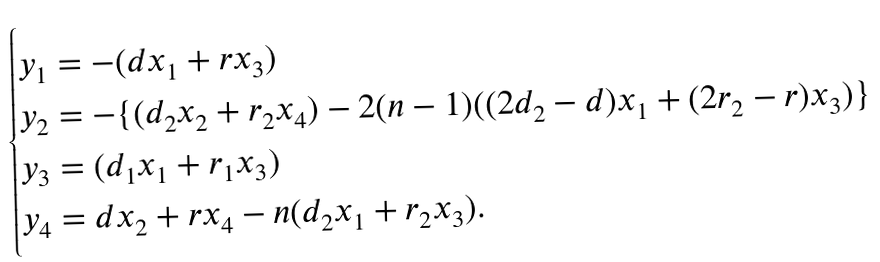Convert formula to latex. <formula><loc_0><loc_0><loc_500><loc_500>\begin{cases} y _ { 1 } = - ( d x _ { 1 } + r x _ { 3 } ) \\ y _ { 2 } = - \{ ( d _ { 2 } x _ { 2 } + r _ { 2 } x _ { 4 } ) - 2 ( n - 1 ) ( ( 2 d _ { 2 } - d ) x _ { 1 } + ( 2 r _ { 2 } - r ) x _ { 3 } ) \} \\ y _ { 3 } = ( d _ { 1 } x _ { 1 } + r _ { 1 } x _ { 3 } ) \\ y _ { 4 } = d x _ { 2 } + r x _ { 4 } - n ( d _ { 2 } x _ { 1 } + r _ { 2 } x _ { 3 } ) . \end{cases}</formula> 